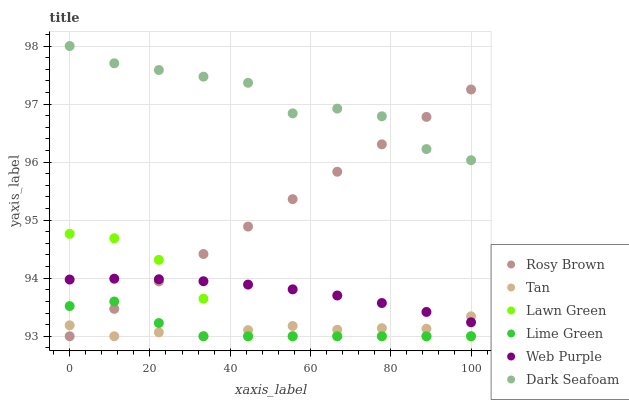Does Tan have the minimum area under the curve?
Answer yes or no. Yes. Does Dark Seafoam have the maximum area under the curve?
Answer yes or no. Yes. Does Rosy Brown have the minimum area under the curve?
Answer yes or no. No. Does Rosy Brown have the maximum area under the curve?
Answer yes or no. No. Is Rosy Brown the smoothest?
Answer yes or no. Yes. Is Dark Seafoam the roughest?
Answer yes or no. Yes. Is Dark Seafoam the smoothest?
Answer yes or no. No. Is Rosy Brown the roughest?
Answer yes or no. No. Does Lawn Green have the lowest value?
Answer yes or no. Yes. Does Dark Seafoam have the lowest value?
Answer yes or no. No. Does Dark Seafoam have the highest value?
Answer yes or no. Yes. Does Rosy Brown have the highest value?
Answer yes or no. No. Is Lawn Green less than Dark Seafoam?
Answer yes or no. Yes. Is Web Purple greater than Lime Green?
Answer yes or no. Yes. Does Rosy Brown intersect Tan?
Answer yes or no. Yes. Is Rosy Brown less than Tan?
Answer yes or no. No. Is Rosy Brown greater than Tan?
Answer yes or no. No. Does Lawn Green intersect Dark Seafoam?
Answer yes or no. No. 